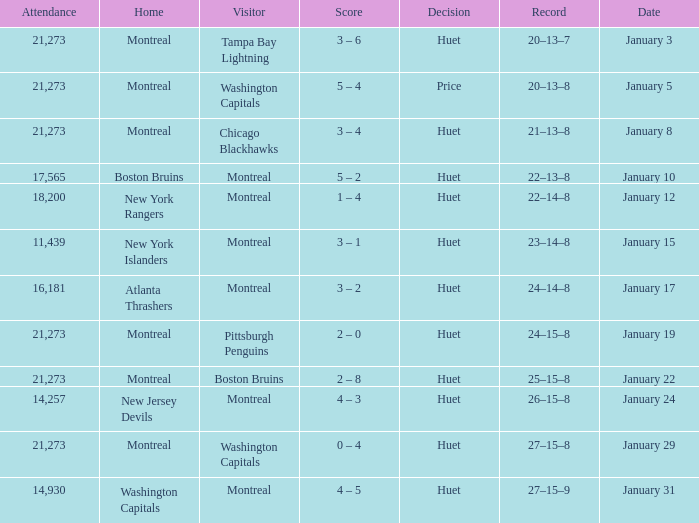What was the score of the game when the Boston Bruins were the visiting team? 2 – 8. 